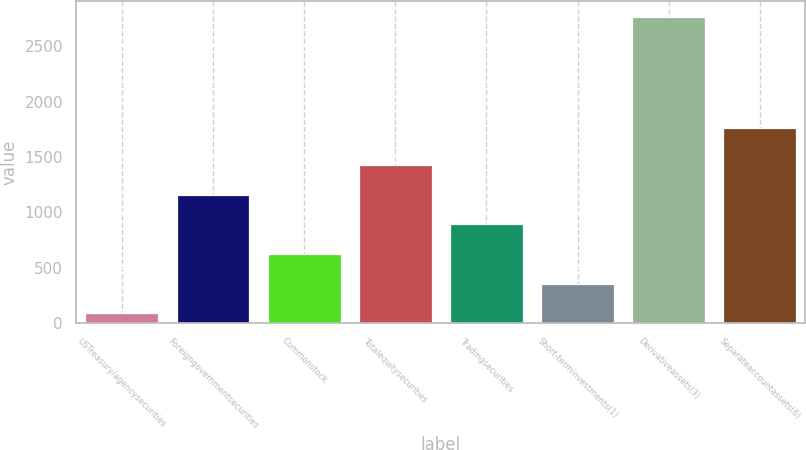Convert chart to OTSL. <chart><loc_0><loc_0><loc_500><loc_500><bar_chart><fcel>USTreasury/agencysecurities<fcel>Foreigngovernmentsecurities<fcel>Commonstock<fcel>Totalequitysecurities<fcel>Tradingsecurities<fcel>Short-terminvestments(1)<fcel>Derivativeassets(3)<fcel>Separateaccountassets(6)<nl><fcel>88<fcel>1160<fcel>624<fcel>1428<fcel>892<fcel>356<fcel>2768<fcel>1758<nl></chart> 